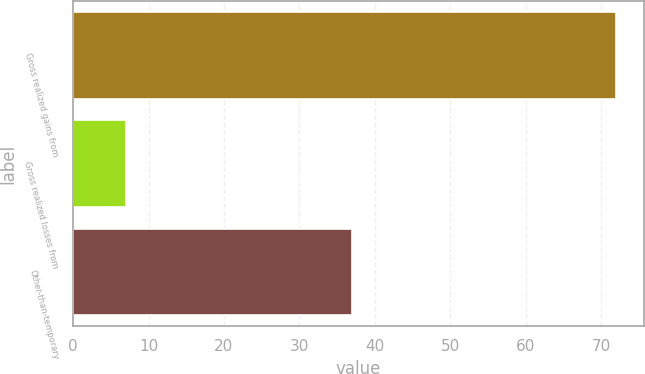<chart> <loc_0><loc_0><loc_500><loc_500><bar_chart><fcel>Gross realized gains from<fcel>Gross realized losses from<fcel>Other-than-temporary<nl><fcel>72<fcel>7<fcel>37<nl></chart> 